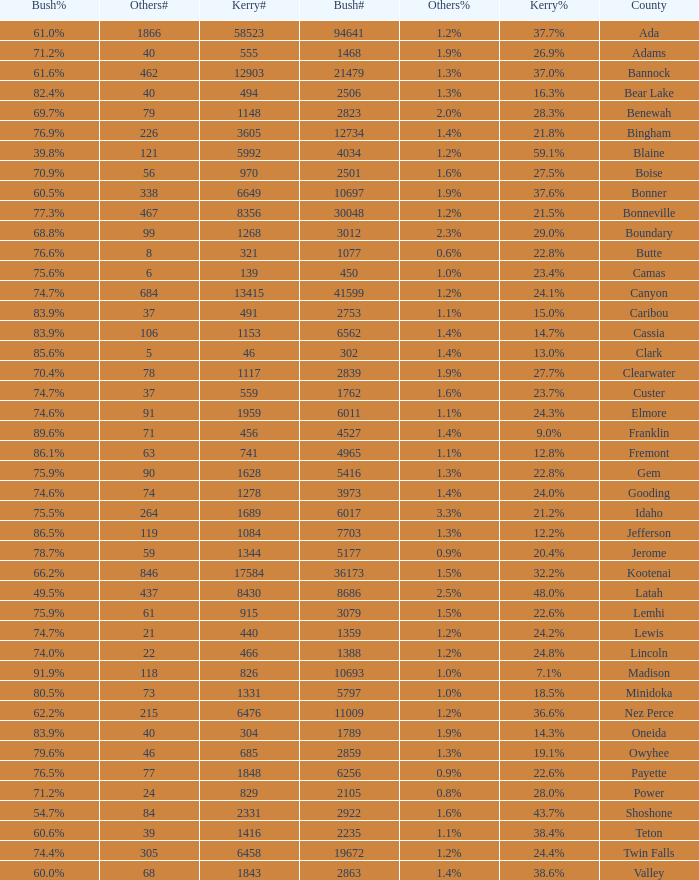How many people voted for Kerry in the county where 8 voted for others? 321.0. 